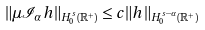Convert formula to latex. <formula><loc_0><loc_0><loc_500><loc_500>\| \mu \mathcal { I } _ { \alpha } h \| _ { H _ { 0 } ^ { s } ( \mathbb { R } ^ { + } ) } \leq c \| h \| _ { H _ { 0 } ^ { s - \alpha } ( \mathbb { R } ^ { + } ) }</formula> 